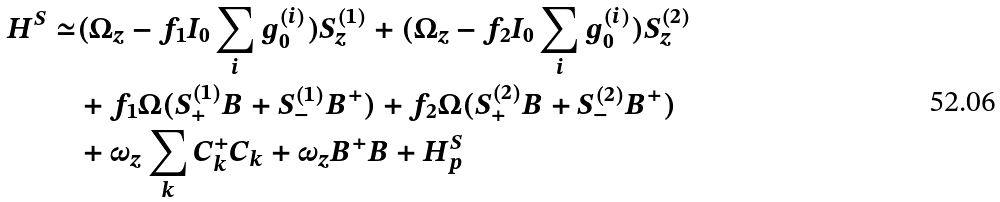<formula> <loc_0><loc_0><loc_500><loc_500>H ^ { S } \simeq & ( \Omega _ { z } - f _ { 1 } I _ { 0 } \sum _ { i } g _ { 0 } ^ { ( i ) } ) S _ { z } ^ { ( 1 ) } + ( \Omega _ { z } - f _ { 2 } I _ { 0 } \sum _ { i } g _ { 0 } ^ { ( i ) } ) S _ { z } ^ { ( 2 ) } \\ & + f _ { 1 } \Omega ( S _ { + } ^ { ( 1 ) } B + S _ { - } ^ { ( 1 ) } B ^ { + } ) + f _ { 2 } \Omega ( S _ { + } ^ { ( 2 ) } B + S _ { - } ^ { ( 2 ) } B ^ { + } ) \\ & + \omega _ { z } \sum _ { k } C _ { k } ^ { + } C _ { k } + \omega _ { z } B ^ { + } B + H _ { p } ^ { S }</formula> 